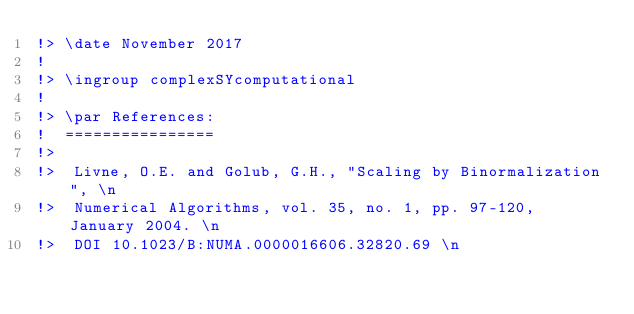Convert code to text. <code><loc_0><loc_0><loc_500><loc_500><_FORTRAN_>!> \date November 2017
!
!> \ingroup complexSYcomputational
!
!> \par References:
!  ================
!>
!>  Livne, O.E. and Golub, G.H., "Scaling by Binormalization", \n
!>  Numerical Algorithms, vol. 35, no. 1, pp. 97-120, January 2004. \n
!>  DOI 10.1023/B:NUMA.0000016606.32820.69 \n</code> 